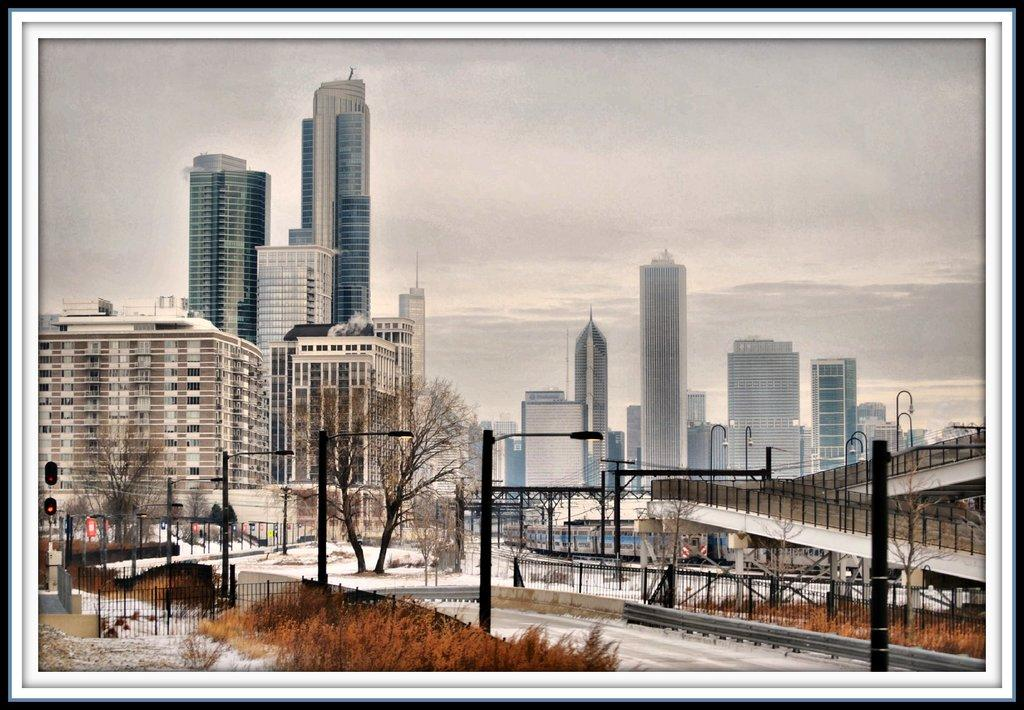What type of structures can be seen in the image? There are buildings in the image. What other natural elements are present in the image? There are trees in the image. What type of lighting is present in the image? Street lights are present in the image. What type of traffic control device is visible in the image? A signal is visible in the image. What type of barrier is present in the image? There is a railing in the image. What type of man-made structure is present in the image that allows for crossing over a body of water or obstacle? A bridge is in the image. What can be seen in the background of the image? The sky is visible in the background of the image. What type of lunch is being served on the bridge in the image? There is no lunch being served in the image, and the bridge is not a location for serving food. How many legs does the signal have in the image? The signal in the image is not a living creature and does not have legs. 